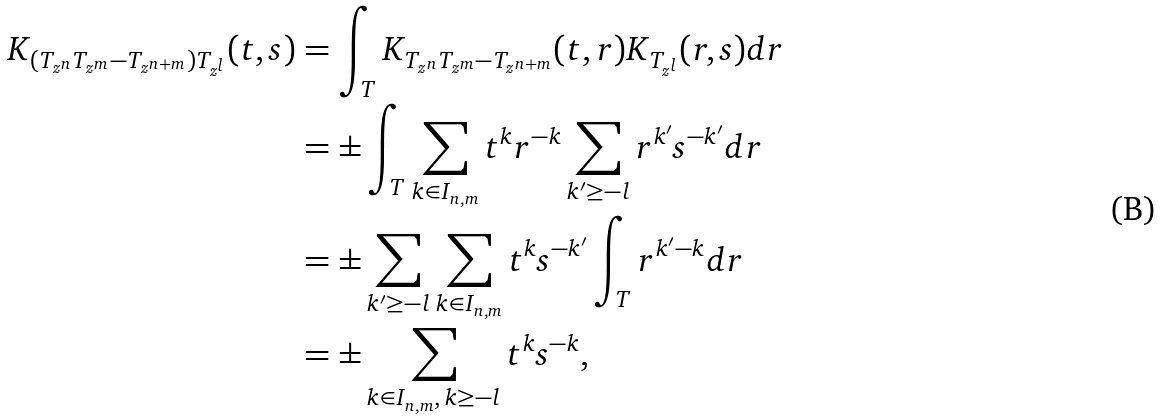Convert formula to latex. <formula><loc_0><loc_0><loc_500><loc_500>K _ { ( T _ { z ^ { n } } T _ { z ^ { m } } - T _ { z ^ { n + m } } ) T _ { z ^ { l } } } ( t , s ) & = \int _ { T } K _ { T _ { z ^ { n } } T _ { z ^ { m } } - T _ { z ^ { n + m } } } ( t , r ) K _ { T _ { z ^ { l } } } ( r , s ) d r \\ & = \pm \int _ { T } \sum _ { k \in I _ { n , m } } t ^ { k } r ^ { - k } \sum _ { k ^ { \prime } \geq - l } r ^ { k ^ { \prime } } s ^ { - k ^ { \prime } } d r \\ & = \pm \sum _ { k ^ { \prime } \geq - l } \sum _ { k \in I _ { n , m } } t ^ { k } s ^ { - k ^ { \prime } } \int _ { T } r ^ { k ^ { \prime } - k } d r \\ & = \pm \sum _ { k \in I _ { n , m } , \, k \geq - l } t ^ { k } s ^ { - k } ,</formula> 